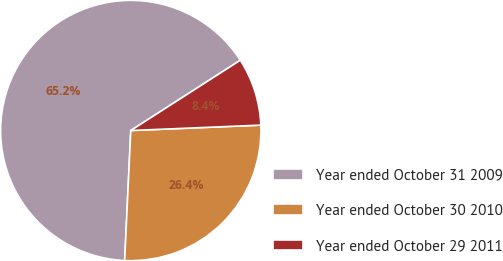Convert chart to OTSL. <chart><loc_0><loc_0><loc_500><loc_500><pie_chart><fcel>Year ended October 31 2009<fcel>Year ended October 30 2010<fcel>Year ended October 29 2011<nl><fcel>65.17%<fcel>26.41%<fcel>8.42%<nl></chart> 